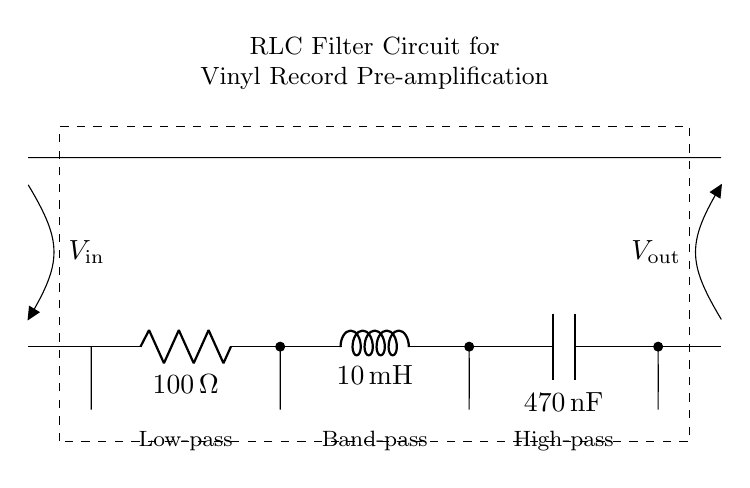What is the value of the resistor in this circuit? The circuit diagram shows a resistor labeled R1, and its value is indicated as 100 ohms next to the component in the diagram.
Answer: 100 ohms What type of filter is represented in this circuit? The diagram indicates that the circuit serves as a low-pass filter, as noted in the labeled section of the diagram.
Answer: Low-pass What components are present in this circuit? The circuit diagram features three key components: a resistor, an inductor, and a capacitor, which are R1, L1, and C1 respectively.
Answer: Resistor, inductor, capacitor What is the inductance value of L1? The circuit diagram specifies that the inductor L1 has a value of 10 milliHenries, indicated next to the inductor in the diagram.
Answer: 10 milliHenries What is the capacitance value of C1? The capacitor labeled C1 in the circuit has a capacitance value of 470 nanofarads, shown alongside the component in the circuit diagram.
Answer: 470 nanofarads How does the presence of R1 affect the filter characteristics? The resistor R1 influences the overall impedance of the circuit, affecting the cutoff frequency and stability of the filter response, particularly in a low-pass configuration.
Answer: Low-pass response What is the function of this RLC circuit in vinyl record pre-amplification? The RLC filter circuit is designed to condition the analog signal from vinyl records, removing unwanted high-frequency noise and improving sound quality before amplification.
Answer: Signal conditioning 